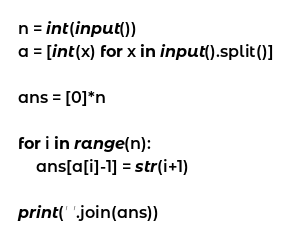<code> <loc_0><loc_0><loc_500><loc_500><_Python_>n = int(input())
a = [int(x) for x in input().split()]

ans = [0]*n

for i in range(n):
    ans[a[i]-1] = str(i+1)

print(' '.join(ans))</code> 